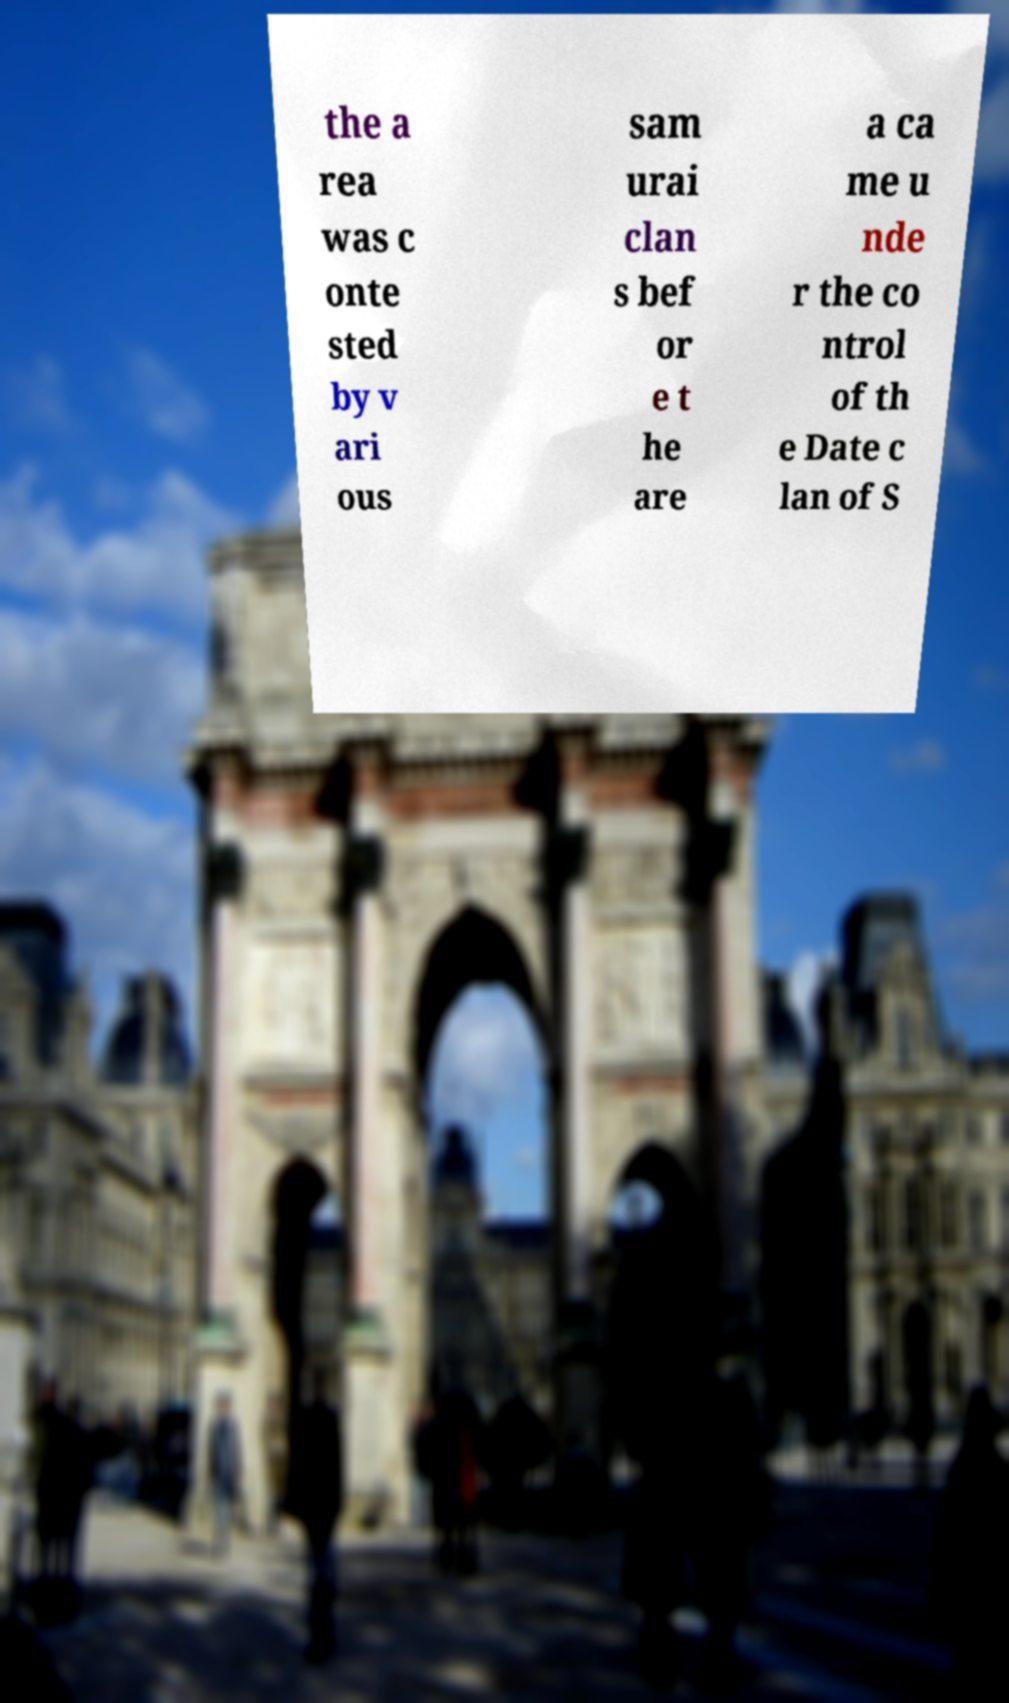Please identify and transcribe the text found in this image. the a rea was c onte sted by v ari ous sam urai clan s bef or e t he are a ca me u nde r the co ntrol of th e Date c lan of S 